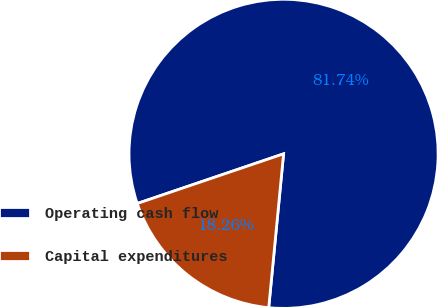<chart> <loc_0><loc_0><loc_500><loc_500><pie_chart><fcel>Operating cash flow<fcel>Capital expenditures<nl><fcel>81.74%<fcel>18.26%<nl></chart> 